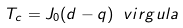<formula> <loc_0><loc_0><loc_500><loc_500>T _ { c } = J _ { 0 } ( d - q ) \ v i r g u l a</formula> 